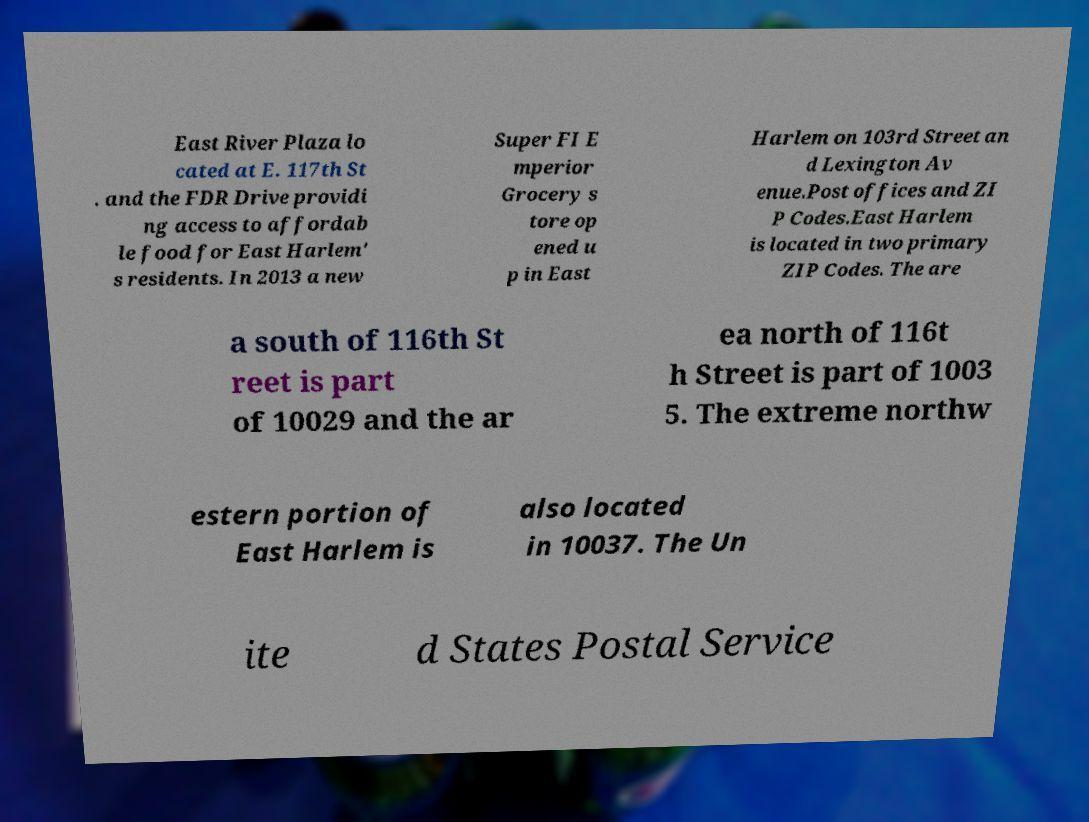Please read and relay the text visible in this image. What does it say? East River Plaza lo cated at E. 117th St . and the FDR Drive providi ng access to affordab le food for East Harlem' s residents. In 2013 a new Super FI E mperior Grocery s tore op ened u p in East Harlem on 103rd Street an d Lexington Av enue.Post offices and ZI P Codes.East Harlem is located in two primary ZIP Codes. The are a south of 116th St reet is part of 10029 and the ar ea north of 116t h Street is part of 1003 5. The extreme northw estern portion of East Harlem is also located in 10037. The Un ite d States Postal Service 